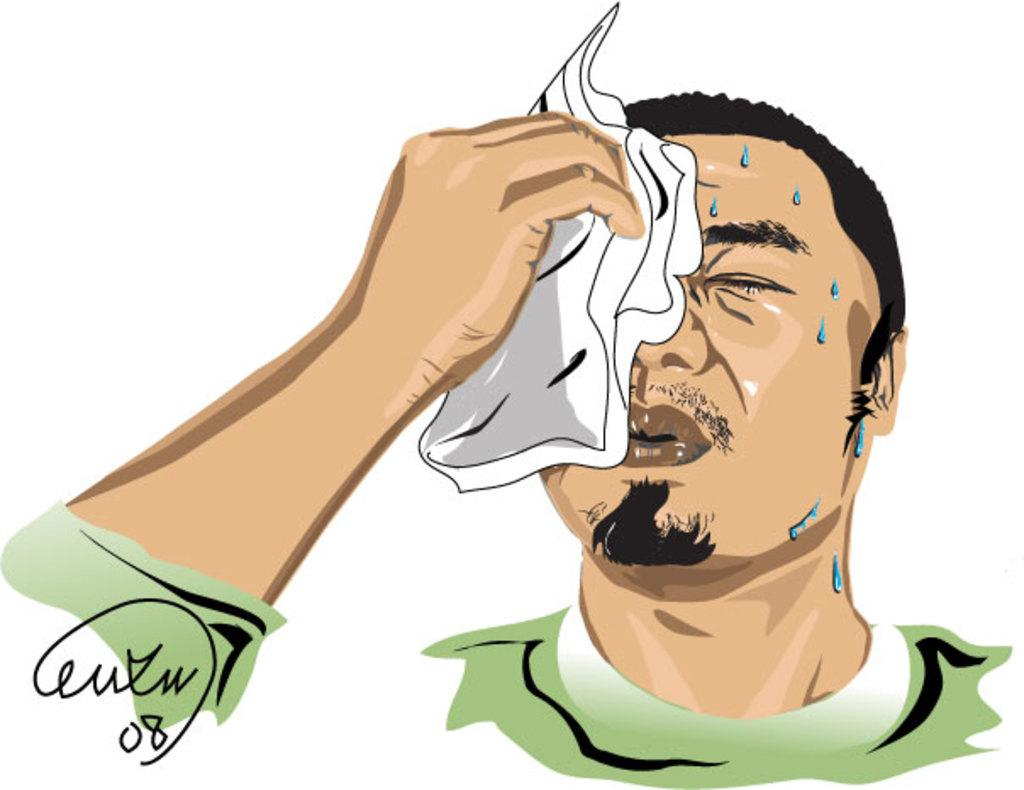What type of artwork is depicted in the image? The image is a painting. Can you describe the person in the painting? There is a person in the painting, and he is holding a handkerchief in his hand. What is the condition of the person's face in the painting? The person's face has water droplets on it. What is the white surface with text in the painting used for? The text on the white surface in the painting is not specified, but it could be a sign or a label. What type of bulb is hanging from the tree in the painting? There is no tree or bulb present in the painting; it features a person with a handkerchief and water droplets on his face. What type of wilderness can be seen in the background of the painting? There is no wilderness or background visible in the painting; it is focused on the person and the white surface with text. 